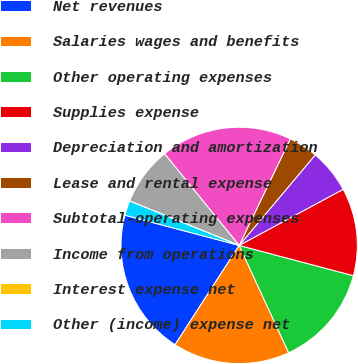<chart> <loc_0><loc_0><loc_500><loc_500><pie_chart><fcel>Net revenues<fcel>Salaries wages and benefits<fcel>Other operating expenses<fcel>Supplies expense<fcel>Depreciation and amortization<fcel>Lease and rental expense<fcel>Subtotal-operating expenses<fcel>Income from operations<fcel>Interest expense net<fcel>Other (income) expense net<nl><fcel>19.99%<fcel>16.0%<fcel>14.0%<fcel>12.0%<fcel>6.0%<fcel>4.0%<fcel>18.0%<fcel>8.0%<fcel>0.01%<fcel>2.0%<nl></chart> 